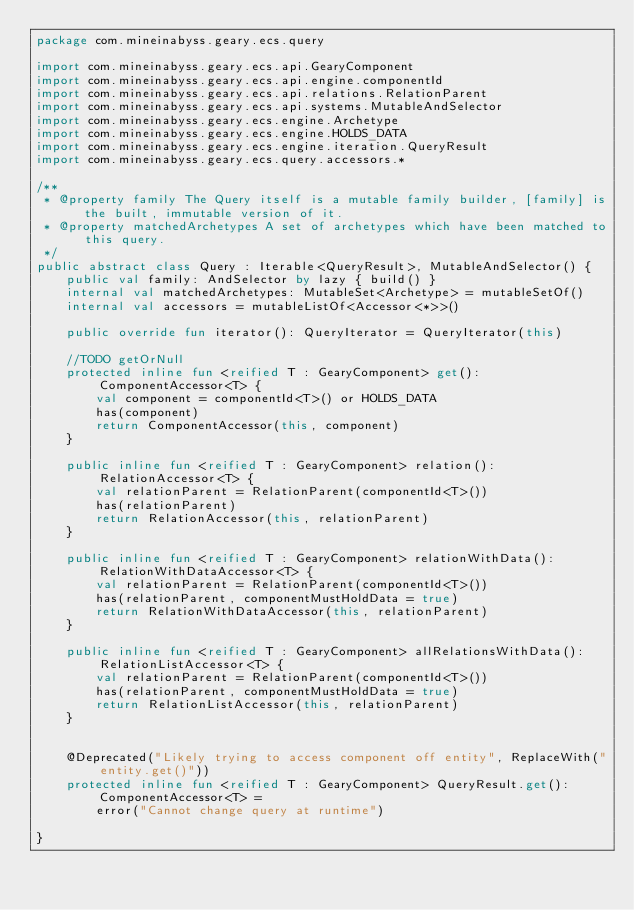<code> <loc_0><loc_0><loc_500><loc_500><_Kotlin_>package com.mineinabyss.geary.ecs.query

import com.mineinabyss.geary.ecs.api.GearyComponent
import com.mineinabyss.geary.ecs.api.engine.componentId
import com.mineinabyss.geary.ecs.api.relations.RelationParent
import com.mineinabyss.geary.ecs.api.systems.MutableAndSelector
import com.mineinabyss.geary.ecs.engine.Archetype
import com.mineinabyss.geary.ecs.engine.HOLDS_DATA
import com.mineinabyss.geary.ecs.engine.iteration.QueryResult
import com.mineinabyss.geary.ecs.query.accessors.*

/**
 * @property family The Query itself is a mutable family builder, [family] is the built, immutable version of it.
 * @property matchedArchetypes A set of archetypes which have been matched to this query.
 */
public abstract class Query : Iterable<QueryResult>, MutableAndSelector() {
    public val family: AndSelector by lazy { build() }
    internal val matchedArchetypes: MutableSet<Archetype> = mutableSetOf()
    internal val accessors = mutableListOf<Accessor<*>>()

    public override fun iterator(): QueryIterator = QueryIterator(this)

    //TODO getOrNull
    protected inline fun <reified T : GearyComponent> get(): ComponentAccessor<T> {
        val component = componentId<T>() or HOLDS_DATA
        has(component)
        return ComponentAccessor(this, component)
    }

    public inline fun <reified T : GearyComponent> relation(): RelationAccessor<T> {
        val relationParent = RelationParent(componentId<T>())
        has(relationParent)
        return RelationAccessor(this, relationParent)
    }

    public inline fun <reified T : GearyComponent> relationWithData(): RelationWithDataAccessor<T> {
        val relationParent = RelationParent(componentId<T>())
        has(relationParent, componentMustHoldData = true)
        return RelationWithDataAccessor(this, relationParent)
    }

    public inline fun <reified T : GearyComponent> allRelationsWithData(): RelationListAccessor<T> {
        val relationParent = RelationParent(componentId<T>())
        has(relationParent, componentMustHoldData = true)
        return RelationListAccessor(this, relationParent)
    }


    @Deprecated("Likely trying to access component off entity", ReplaceWith("entity.get()"))
    protected inline fun <reified T : GearyComponent> QueryResult.get(): ComponentAccessor<T> =
        error("Cannot change query at runtime")

}
</code> 